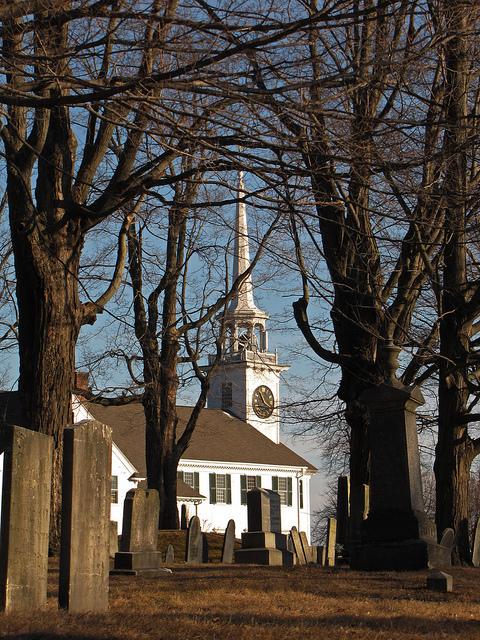Is this a new cemetery?
Quick response, please. No. Is there a clock on the church?
Be succinct. Yes. Is there a cemetery in this photo?
Short answer required. Yes. 